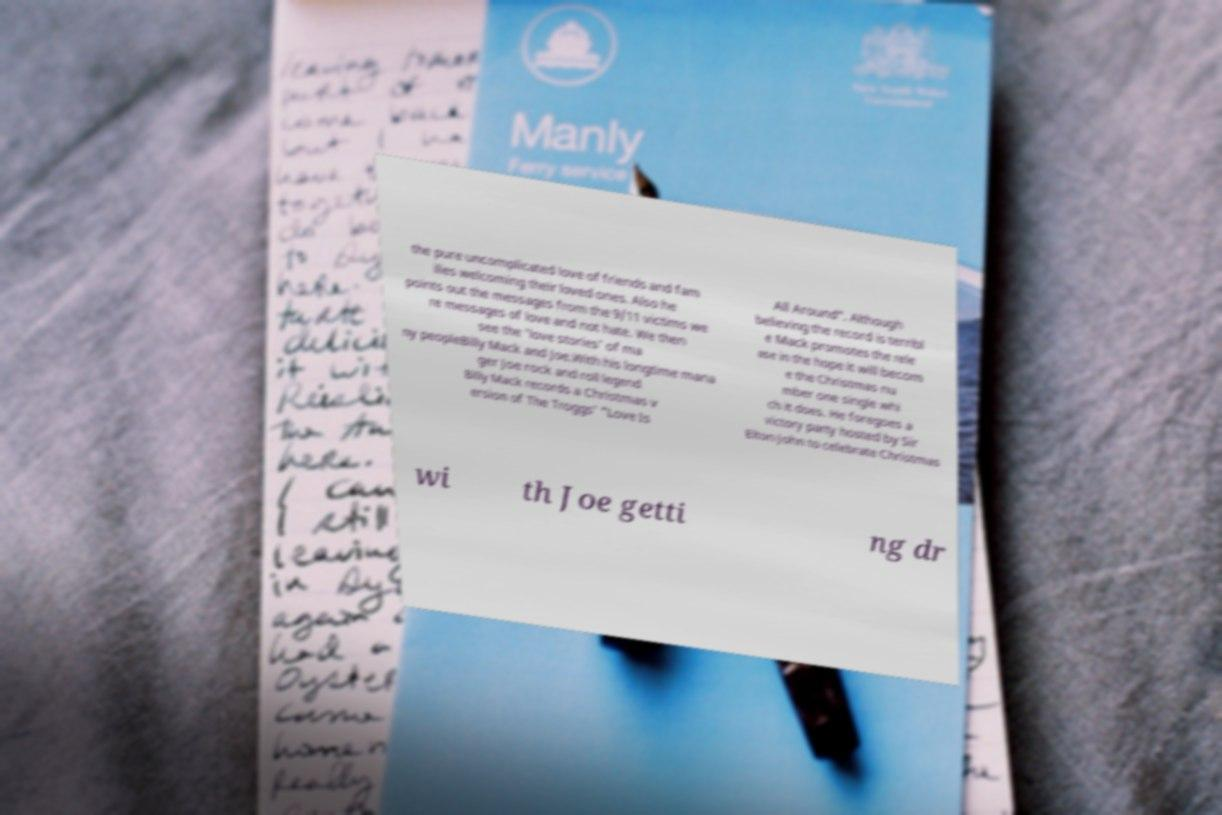What messages or text are displayed in this image? I need them in a readable, typed format. the pure uncomplicated love of friends and fam ilies welcoming their loved ones. Also he points out the messages from the 9/11 victims we re messages of love and not hate. We then see the 'love stories' of ma ny peopleBilly Mack and Joe.With his longtime mana ger Joe rock and roll legend Billy Mack records a Christmas v ersion of The Troggs' "Love Is All Around". Although believing the record is terribl e Mack promotes the rele ase in the hope it will becom e the Christmas nu mber one single whi ch it does. He foregoes a victory party hosted by Sir Elton John to celebrate Christmas wi th Joe getti ng dr 